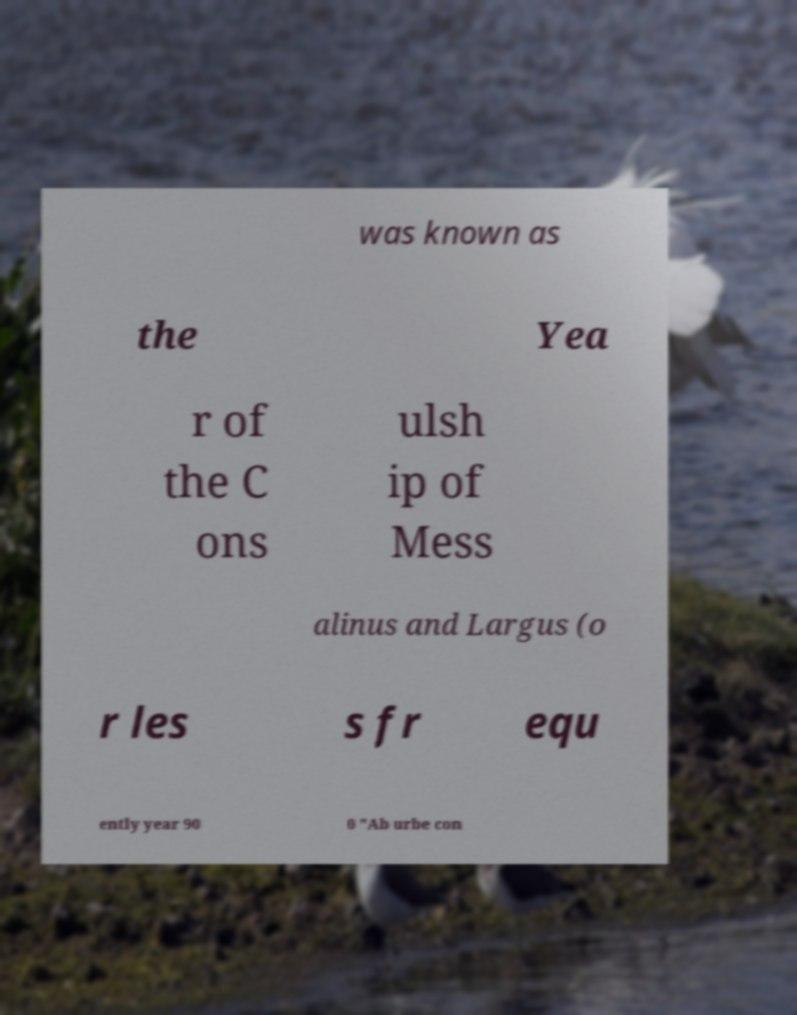Please read and relay the text visible in this image. What does it say? was known as the Yea r of the C ons ulsh ip of Mess alinus and Largus (o r les s fr equ ently year 90 0 "Ab urbe con 